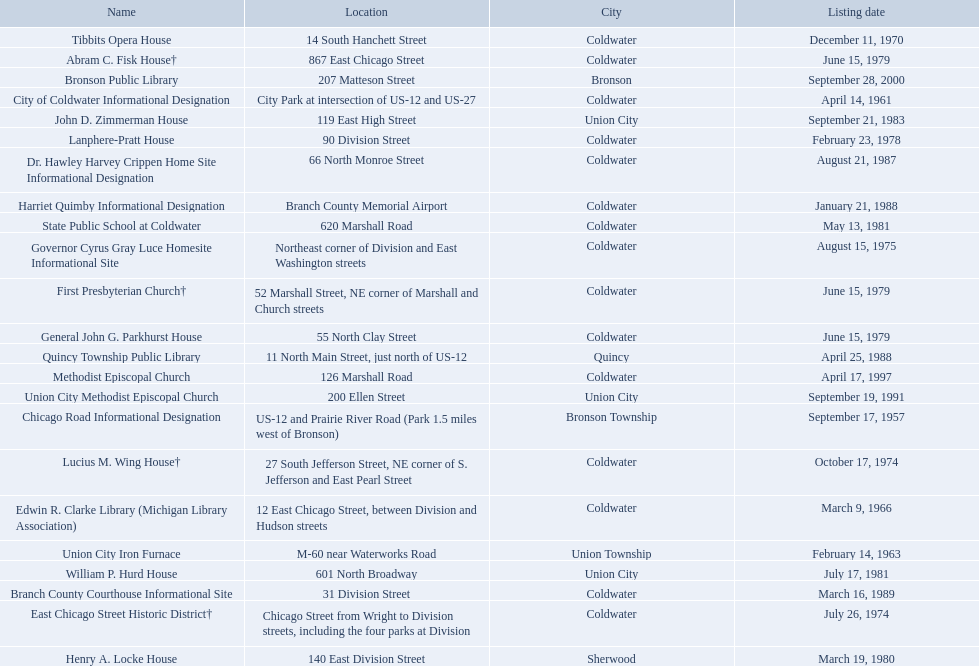In branch co. mi what historic sites are located on a near a highway? Chicago Road Informational Designation, City of Coldwater Informational Designation, Quincy Township Public Library, Union City Iron Furnace. Of the historic sites ins branch co. near highways, which ones are near only us highways? Chicago Road Informational Designation, City of Coldwater Informational Designation, Quincy Township Public Library. Which historical sites in branch co. are near only us highways and are not a building? Chicago Road Informational Designation, City of Coldwater Informational Designation. Which non-building historical sites in branch county near a us highways is closest to bronson? Chicago Road Informational Designation. 